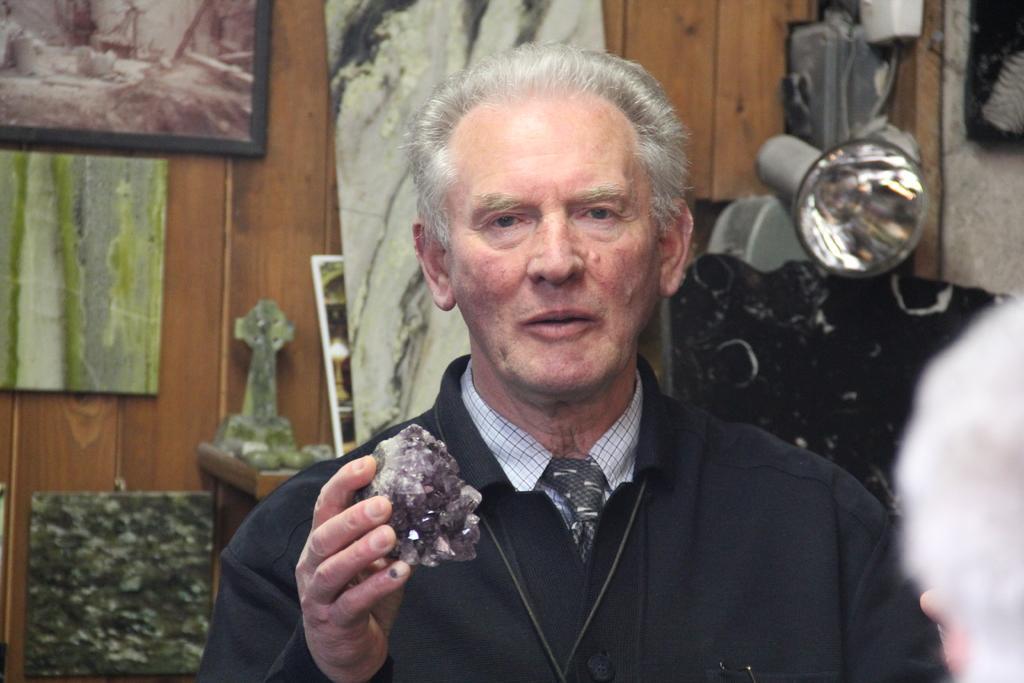Describe this image in one or two sentences. The picture is taken in a room. In the foreground of the picture there is a man holding a stone, behind him there are frames, stones and a light. 